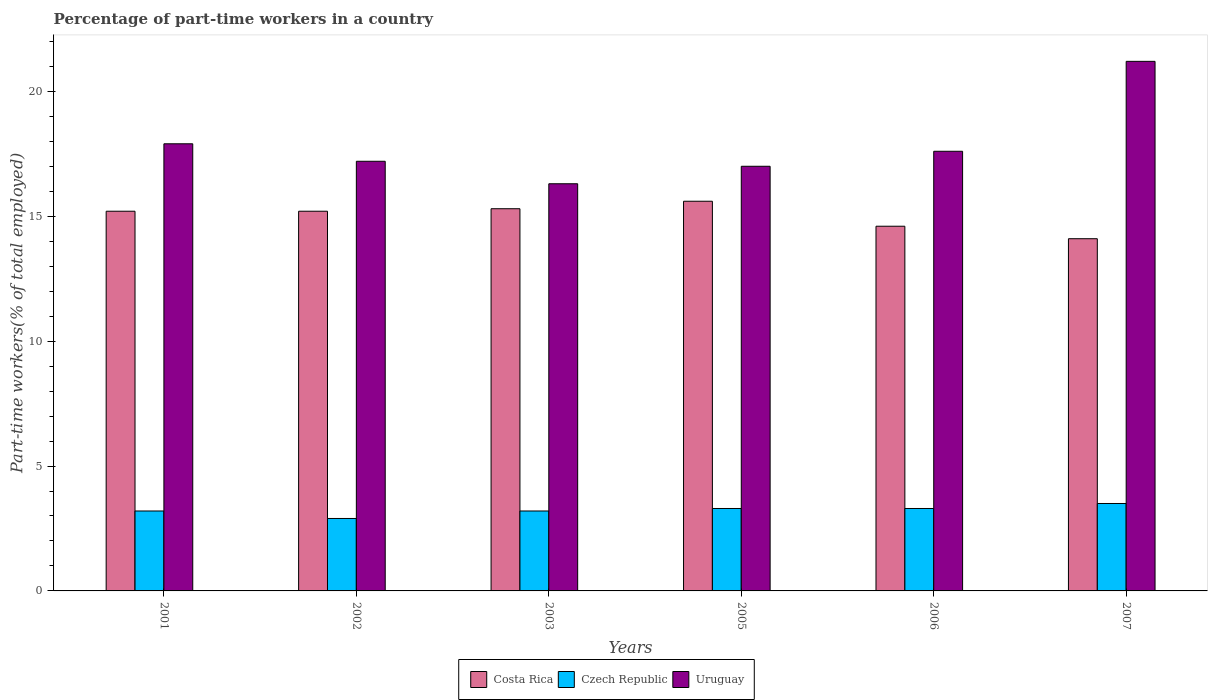Are the number of bars per tick equal to the number of legend labels?
Offer a very short reply. Yes. What is the percentage of part-time workers in Czech Republic in 2003?
Offer a very short reply. 3.2. Across all years, what is the maximum percentage of part-time workers in Costa Rica?
Your answer should be very brief. 15.6. Across all years, what is the minimum percentage of part-time workers in Czech Republic?
Ensure brevity in your answer.  2.9. In which year was the percentage of part-time workers in Costa Rica maximum?
Keep it short and to the point. 2005. What is the total percentage of part-time workers in Costa Rica in the graph?
Keep it short and to the point. 90. What is the difference between the percentage of part-time workers in Uruguay in 2002 and that in 2005?
Keep it short and to the point. 0.2. What is the difference between the percentage of part-time workers in Czech Republic in 2001 and the percentage of part-time workers in Costa Rica in 2002?
Keep it short and to the point. -12. What is the average percentage of part-time workers in Czech Republic per year?
Give a very brief answer. 3.23. In the year 2003, what is the difference between the percentage of part-time workers in Uruguay and percentage of part-time workers in Costa Rica?
Give a very brief answer. 1. In how many years, is the percentage of part-time workers in Costa Rica greater than 3 %?
Provide a succinct answer. 6. What is the ratio of the percentage of part-time workers in Costa Rica in 2001 to that in 2003?
Offer a terse response. 0.99. What is the difference between the highest and the second highest percentage of part-time workers in Costa Rica?
Offer a very short reply. 0.3. What is the difference between the highest and the lowest percentage of part-time workers in Uruguay?
Ensure brevity in your answer.  4.9. What does the 2nd bar from the left in 2002 represents?
Ensure brevity in your answer.  Czech Republic. What does the 1st bar from the right in 2001 represents?
Ensure brevity in your answer.  Uruguay. Are the values on the major ticks of Y-axis written in scientific E-notation?
Provide a short and direct response. No. Where does the legend appear in the graph?
Make the answer very short. Bottom center. How are the legend labels stacked?
Provide a short and direct response. Horizontal. What is the title of the graph?
Make the answer very short. Percentage of part-time workers in a country. What is the label or title of the Y-axis?
Offer a very short reply. Part-time workers(% of total employed). What is the Part-time workers(% of total employed) in Costa Rica in 2001?
Your answer should be very brief. 15.2. What is the Part-time workers(% of total employed) of Czech Republic in 2001?
Give a very brief answer. 3.2. What is the Part-time workers(% of total employed) of Uruguay in 2001?
Your response must be concise. 17.9. What is the Part-time workers(% of total employed) of Costa Rica in 2002?
Give a very brief answer. 15.2. What is the Part-time workers(% of total employed) of Czech Republic in 2002?
Ensure brevity in your answer.  2.9. What is the Part-time workers(% of total employed) in Uruguay in 2002?
Your response must be concise. 17.2. What is the Part-time workers(% of total employed) in Costa Rica in 2003?
Keep it short and to the point. 15.3. What is the Part-time workers(% of total employed) of Czech Republic in 2003?
Keep it short and to the point. 3.2. What is the Part-time workers(% of total employed) of Uruguay in 2003?
Ensure brevity in your answer.  16.3. What is the Part-time workers(% of total employed) in Costa Rica in 2005?
Make the answer very short. 15.6. What is the Part-time workers(% of total employed) of Czech Republic in 2005?
Your response must be concise. 3.3. What is the Part-time workers(% of total employed) in Costa Rica in 2006?
Keep it short and to the point. 14.6. What is the Part-time workers(% of total employed) in Czech Republic in 2006?
Your answer should be very brief. 3.3. What is the Part-time workers(% of total employed) in Uruguay in 2006?
Provide a succinct answer. 17.6. What is the Part-time workers(% of total employed) in Costa Rica in 2007?
Offer a very short reply. 14.1. What is the Part-time workers(% of total employed) of Czech Republic in 2007?
Offer a terse response. 3.5. What is the Part-time workers(% of total employed) in Uruguay in 2007?
Make the answer very short. 21.2. Across all years, what is the maximum Part-time workers(% of total employed) in Costa Rica?
Provide a short and direct response. 15.6. Across all years, what is the maximum Part-time workers(% of total employed) in Czech Republic?
Your answer should be compact. 3.5. Across all years, what is the maximum Part-time workers(% of total employed) of Uruguay?
Make the answer very short. 21.2. Across all years, what is the minimum Part-time workers(% of total employed) in Costa Rica?
Keep it short and to the point. 14.1. Across all years, what is the minimum Part-time workers(% of total employed) of Czech Republic?
Ensure brevity in your answer.  2.9. Across all years, what is the minimum Part-time workers(% of total employed) in Uruguay?
Your answer should be compact. 16.3. What is the total Part-time workers(% of total employed) of Uruguay in the graph?
Keep it short and to the point. 107.2. What is the difference between the Part-time workers(% of total employed) in Costa Rica in 2001 and that in 2002?
Keep it short and to the point. 0. What is the difference between the Part-time workers(% of total employed) in Uruguay in 2001 and that in 2002?
Offer a very short reply. 0.7. What is the difference between the Part-time workers(% of total employed) in Costa Rica in 2001 and that in 2003?
Offer a very short reply. -0.1. What is the difference between the Part-time workers(% of total employed) in Czech Republic in 2001 and that in 2003?
Your response must be concise. 0. What is the difference between the Part-time workers(% of total employed) of Czech Republic in 2001 and that in 2005?
Provide a succinct answer. -0.1. What is the difference between the Part-time workers(% of total employed) of Costa Rica in 2001 and that in 2006?
Provide a short and direct response. 0.6. What is the difference between the Part-time workers(% of total employed) of Uruguay in 2001 and that in 2006?
Your answer should be very brief. 0.3. What is the difference between the Part-time workers(% of total employed) of Costa Rica in 2001 and that in 2007?
Keep it short and to the point. 1.1. What is the difference between the Part-time workers(% of total employed) in Uruguay in 2001 and that in 2007?
Provide a short and direct response. -3.3. What is the difference between the Part-time workers(% of total employed) of Uruguay in 2002 and that in 2003?
Your response must be concise. 0.9. What is the difference between the Part-time workers(% of total employed) in Costa Rica in 2002 and that in 2005?
Ensure brevity in your answer.  -0.4. What is the difference between the Part-time workers(% of total employed) in Uruguay in 2002 and that in 2005?
Your answer should be very brief. 0.2. What is the difference between the Part-time workers(% of total employed) of Costa Rica in 2002 and that in 2006?
Provide a succinct answer. 0.6. What is the difference between the Part-time workers(% of total employed) in Czech Republic in 2002 and that in 2006?
Provide a short and direct response. -0.4. What is the difference between the Part-time workers(% of total employed) of Uruguay in 2002 and that in 2006?
Ensure brevity in your answer.  -0.4. What is the difference between the Part-time workers(% of total employed) of Costa Rica in 2002 and that in 2007?
Give a very brief answer. 1.1. What is the difference between the Part-time workers(% of total employed) in Czech Republic in 2003 and that in 2007?
Your response must be concise. -0.3. What is the difference between the Part-time workers(% of total employed) of Costa Rica in 2005 and that in 2006?
Ensure brevity in your answer.  1. What is the difference between the Part-time workers(% of total employed) of Czech Republic in 2005 and that in 2006?
Offer a terse response. 0. What is the difference between the Part-time workers(% of total employed) in Czech Republic in 2005 and that in 2007?
Your answer should be very brief. -0.2. What is the difference between the Part-time workers(% of total employed) of Uruguay in 2005 and that in 2007?
Keep it short and to the point. -4.2. What is the difference between the Part-time workers(% of total employed) in Costa Rica in 2001 and the Part-time workers(% of total employed) in Uruguay in 2003?
Your response must be concise. -1.1. What is the difference between the Part-time workers(% of total employed) in Costa Rica in 2001 and the Part-time workers(% of total employed) in Czech Republic in 2005?
Offer a terse response. 11.9. What is the difference between the Part-time workers(% of total employed) of Costa Rica in 2001 and the Part-time workers(% of total employed) of Uruguay in 2005?
Your answer should be very brief. -1.8. What is the difference between the Part-time workers(% of total employed) in Costa Rica in 2001 and the Part-time workers(% of total employed) in Czech Republic in 2006?
Your answer should be very brief. 11.9. What is the difference between the Part-time workers(% of total employed) in Czech Republic in 2001 and the Part-time workers(% of total employed) in Uruguay in 2006?
Your answer should be compact. -14.4. What is the difference between the Part-time workers(% of total employed) of Costa Rica in 2001 and the Part-time workers(% of total employed) of Czech Republic in 2007?
Ensure brevity in your answer.  11.7. What is the difference between the Part-time workers(% of total employed) in Costa Rica in 2001 and the Part-time workers(% of total employed) in Uruguay in 2007?
Make the answer very short. -6. What is the difference between the Part-time workers(% of total employed) of Czech Republic in 2001 and the Part-time workers(% of total employed) of Uruguay in 2007?
Offer a very short reply. -18. What is the difference between the Part-time workers(% of total employed) in Costa Rica in 2002 and the Part-time workers(% of total employed) in Uruguay in 2003?
Your response must be concise. -1.1. What is the difference between the Part-time workers(% of total employed) of Czech Republic in 2002 and the Part-time workers(% of total employed) of Uruguay in 2003?
Your answer should be compact. -13.4. What is the difference between the Part-time workers(% of total employed) in Costa Rica in 2002 and the Part-time workers(% of total employed) in Czech Republic in 2005?
Ensure brevity in your answer.  11.9. What is the difference between the Part-time workers(% of total employed) of Czech Republic in 2002 and the Part-time workers(% of total employed) of Uruguay in 2005?
Provide a succinct answer. -14.1. What is the difference between the Part-time workers(% of total employed) in Czech Republic in 2002 and the Part-time workers(% of total employed) in Uruguay in 2006?
Make the answer very short. -14.7. What is the difference between the Part-time workers(% of total employed) of Costa Rica in 2002 and the Part-time workers(% of total employed) of Czech Republic in 2007?
Give a very brief answer. 11.7. What is the difference between the Part-time workers(% of total employed) in Czech Republic in 2002 and the Part-time workers(% of total employed) in Uruguay in 2007?
Make the answer very short. -18.3. What is the difference between the Part-time workers(% of total employed) in Czech Republic in 2003 and the Part-time workers(% of total employed) in Uruguay in 2005?
Offer a terse response. -13.8. What is the difference between the Part-time workers(% of total employed) of Costa Rica in 2003 and the Part-time workers(% of total employed) of Uruguay in 2006?
Ensure brevity in your answer.  -2.3. What is the difference between the Part-time workers(% of total employed) of Czech Republic in 2003 and the Part-time workers(% of total employed) of Uruguay in 2006?
Make the answer very short. -14.4. What is the difference between the Part-time workers(% of total employed) in Costa Rica in 2003 and the Part-time workers(% of total employed) in Czech Republic in 2007?
Provide a succinct answer. 11.8. What is the difference between the Part-time workers(% of total employed) of Costa Rica in 2003 and the Part-time workers(% of total employed) of Uruguay in 2007?
Provide a succinct answer. -5.9. What is the difference between the Part-time workers(% of total employed) in Czech Republic in 2003 and the Part-time workers(% of total employed) in Uruguay in 2007?
Keep it short and to the point. -18. What is the difference between the Part-time workers(% of total employed) in Costa Rica in 2005 and the Part-time workers(% of total employed) in Czech Republic in 2006?
Provide a short and direct response. 12.3. What is the difference between the Part-time workers(% of total employed) in Czech Republic in 2005 and the Part-time workers(% of total employed) in Uruguay in 2006?
Your response must be concise. -14.3. What is the difference between the Part-time workers(% of total employed) in Costa Rica in 2005 and the Part-time workers(% of total employed) in Uruguay in 2007?
Make the answer very short. -5.6. What is the difference between the Part-time workers(% of total employed) of Czech Republic in 2005 and the Part-time workers(% of total employed) of Uruguay in 2007?
Provide a succinct answer. -17.9. What is the difference between the Part-time workers(% of total employed) in Czech Republic in 2006 and the Part-time workers(% of total employed) in Uruguay in 2007?
Provide a short and direct response. -17.9. What is the average Part-time workers(% of total employed) in Czech Republic per year?
Give a very brief answer. 3.23. What is the average Part-time workers(% of total employed) in Uruguay per year?
Your answer should be compact. 17.87. In the year 2001, what is the difference between the Part-time workers(% of total employed) of Costa Rica and Part-time workers(% of total employed) of Czech Republic?
Give a very brief answer. 12. In the year 2001, what is the difference between the Part-time workers(% of total employed) of Costa Rica and Part-time workers(% of total employed) of Uruguay?
Offer a terse response. -2.7. In the year 2001, what is the difference between the Part-time workers(% of total employed) of Czech Republic and Part-time workers(% of total employed) of Uruguay?
Ensure brevity in your answer.  -14.7. In the year 2002, what is the difference between the Part-time workers(% of total employed) of Costa Rica and Part-time workers(% of total employed) of Uruguay?
Give a very brief answer. -2. In the year 2002, what is the difference between the Part-time workers(% of total employed) of Czech Republic and Part-time workers(% of total employed) of Uruguay?
Provide a short and direct response. -14.3. In the year 2003, what is the difference between the Part-time workers(% of total employed) in Costa Rica and Part-time workers(% of total employed) in Czech Republic?
Your answer should be very brief. 12.1. In the year 2003, what is the difference between the Part-time workers(% of total employed) in Costa Rica and Part-time workers(% of total employed) in Uruguay?
Make the answer very short. -1. In the year 2005, what is the difference between the Part-time workers(% of total employed) of Costa Rica and Part-time workers(% of total employed) of Czech Republic?
Your answer should be compact. 12.3. In the year 2005, what is the difference between the Part-time workers(% of total employed) of Costa Rica and Part-time workers(% of total employed) of Uruguay?
Ensure brevity in your answer.  -1.4. In the year 2005, what is the difference between the Part-time workers(% of total employed) in Czech Republic and Part-time workers(% of total employed) in Uruguay?
Offer a very short reply. -13.7. In the year 2006, what is the difference between the Part-time workers(% of total employed) in Costa Rica and Part-time workers(% of total employed) in Czech Republic?
Offer a terse response. 11.3. In the year 2006, what is the difference between the Part-time workers(% of total employed) of Czech Republic and Part-time workers(% of total employed) of Uruguay?
Ensure brevity in your answer.  -14.3. In the year 2007, what is the difference between the Part-time workers(% of total employed) in Czech Republic and Part-time workers(% of total employed) in Uruguay?
Your answer should be very brief. -17.7. What is the ratio of the Part-time workers(% of total employed) of Czech Republic in 2001 to that in 2002?
Your response must be concise. 1.1. What is the ratio of the Part-time workers(% of total employed) in Uruguay in 2001 to that in 2002?
Your response must be concise. 1.04. What is the ratio of the Part-time workers(% of total employed) in Czech Republic in 2001 to that in 2003?
Your response must be concise. 1. What is the ratio of the Part-time workers(% of total employed) in Uruguay in 2001 to that in 2003?
Offer a very short reply. 1.1. What is the ratio of the Part-time workers(% of total employed) of Costa Rica in 2001 to that in 2005?
Provide a short and direct response. 0.97. What is the ratio of the Part-time workers(% of total employed) of Czech Republic in 2001 to that in 2005?
Provide a succinct answer. 0.97. What is the ratio of the Part-time workers(% of total employed) in Uruguay in 2001 to that in 2005?
Your answer should be compact. 1.05. What is the ratio of the Part-time workers(% of total employed) of Costa Rica in 2001 to that in 2006?
Offer a very short reply. 1.04. What is the ratio of the Part-time workers(% of total employed) in Czech Republic in 2001 to that in 2006?
Your response must be concise. 0.97. What is the ratio of the Part-time workers(% of total employed) in Costa Rica in 2001 to that in 2007?
Provide a succinct answer. 1.08. What is the ratio of the Part-time workers(% of total employed) of Czech Republic in 2001 to that in 2007?
Keep it short and to the point. 0.91. What is the ratio of the Part-time workers(% of total employed) of Uruguay in 2001 to that in 2007?
Provide a succinct answer. 0.84. What is the ratio of the Part-time workers(% of total employed) of Czech Republic in 2002 to that in 2003?
Keep it short and to the point. 0.91. What is the ratio of the Part-time workers(% of total employed) in Uruguay in 2002 to that in 2003?
Your answer should be very brief. 1.06. What is the ratio of the Part-time workers(% of total employed) of Costa Rica in 2002 to that in 2005?
Provide a short and direct response. 0.97. What is the ratio of the Part-time workers(% of total employed) in Czech Republic in 2002 to that in 2005?
Your answer should be compact. 0.88. What is the ratio of the Part-time workers(% of total employed) in Uruguay in 2002 to that in 2005?
Provide a short and direct response. 1.01. What is the ratio of the Part-time workers(% of total employed) of Costa Rica in 2002 to that in 2006?
Ensure brevity in your answer.  1.04. What is the ratio of the Part-time workers(% of total employed) of Czech Republic in 2002 to that in 2006?
Your answer should be very brief. 0.88. What is the ratio of the Part-time workers(% of total employed) of Uruguay in 2002 to that in 2006?
Keep it short and to the point. 0.98. What is the ratio of the Part-time workers(% of total employed) of Costa Rica in 2002 to that in 2007?
Your response must be concise. 1.08. What is the ratio of the Part-time workers(% of total employed) of Czech Republic in 2002 to that in 2007?
Your answer should be compact. 0.83. What is the ratio of the Part-time workers(% of total employed) in Uruguay in 2002 to that in 2007?
Make the answer very short. 0.81. What is the ratio of the Part-time workers(% of total employed) of Costa Rica in 2003 to that in 2005?
Offer a very short reply. 0.98. What is the ratio of the Part-time workers(% of total employed) of Czech Republic in 2003 to that in 2005?
Offer a very short reply. 0.97. What is the ratio of the Part-time workers(% of total employed) in Uruguay in 2003 to that in 2005?
Your answer should be very brief. 0.96. What is the ratio of the Part-time workers(% of total employed) of Costa Rica in 2003 to that in 2006?
Give a very brief answer. 1.05. What is the ratio of the Part-time workers(% of total employed) of Czech Republic in 2003 to that in 2006?
Your response must be concise. 0.97. What is the ratio of the Part-time workers(% of total employed) of Uruguay in 2003 to that in 2006?
Offer a very short reply. 0.93. What is the ratio of the Part-time workers(% of total employed) of Costa Rica in 2003 to that in 2007?
Keep it short and to the point. 1.09. What is the ratio of the Part-time workers(% of total employed) of Czech Republic in 2003 to that in 2007?
Make the answer very short. 0.91. What is the ratio of the Part-time workers(% of total employed) in Uruguay in 2003 to that in 2007?
Offer a very short reply. 0.77. What is the ratio of the Part-time workers(% of total employed) of Costa Rica in 2005 to that in 2006?
Provide a succinct answer. 1.07. What is the ratio of the Part-time workers(% of total employed) of Uruguay in 2005 to that in 2006?
Make the answer very short. 0.97. What is the ratio of the Part-time workers(% of total employed) in Costa Rica in 2005 to that in 2007?
Your answer should be very brief. 1.11. What is the ratio of the Part-time workers(% of total employed) in Czech Republic in 2005 to that in 2007?
Provide a succinct answer. 0.94. What is the ratio of the Part-time workers(% of total employed) in Uruguay in 2005 to that in 2007?
Your answer should be compact. 0.8. What is the ratio of the Part-time workers(% of total employed) of Costa Rica in 2006 to that in 2007?
Offer a very short reply. 1.04. What is the ratio of the Part-time workers(% of total employed) of Czech Republic in 2006 to that in 2007?
Your response must be concise. 0.94. What is the ratio of the Part-time workers(% of total employed) in Uruguay in 2006 to that in 2007?
Offer a terse response. 0.83. What is the difference between the highest and the second highest Part-time workers(% of total employed) of Costa Rica?
Your answer should be compact. 0.3. What is the difference between the highest and the lowest Part-time workers(% of total employed) in Costa Rica?
Your answer should be very brief. 1.5. 